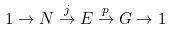Convert formula to latex. <formula><loc_0><loc_0><loc_500><loc_500>1 \to N \overset { j } { \to } E \overset { p } { \to } G \to 1</formula> 